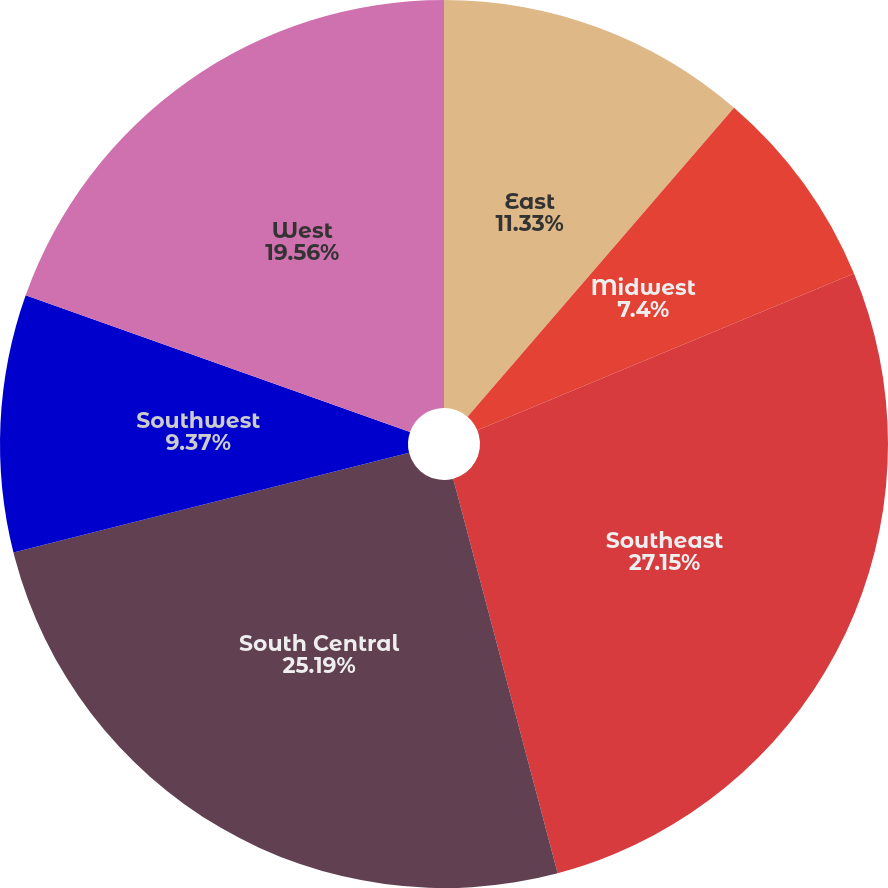Convert chart to OTSL. <chart><loc_0><loc_0><loc_500><loc_500><pie_chart><fcel>East<fcel>Midwest<fcel>Southeast<fcel>South Central<fcel>Southwest<fcel>West<nl><fcel>11.33%<fcel>7.4%<fcel>27.15%<fcel>25.19%<fcel>9.37%<fcel>19.56%<nl></chart> 